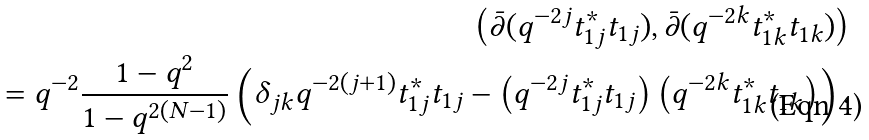Convert formula to latex. <formula><loc_0><loc_0><loc_500><loc_500>\left ( \bar { \partial } ( q ^ { - 2 j } t _ { 1 j } ^ { * } t _ { 1 j } ) , \bar { \partial } ( q ^ { - 2 k } t _ { 1 k } ^ { * } t _ { 1 k } ) \right ) \\ = q ^ { - 2 } \frac { 1 - q ^ { 2 } } { 1 - q ^ { 2 ( N - 1 ) } } \left ( \delta _ { j k } q ^ { - 2 ( j + 1 ) } t _ { 1 j } ^ { * } t _ { 1 j } - \left ( q ^ { - 2 j } t _ { 1 j } ^ { * } t _ { 1 j } \right ) \left ( q ^ { - 2 k } t _ { 1 k } ^ { * } t _ { 1 k } \right ) \right ) .</formula> 